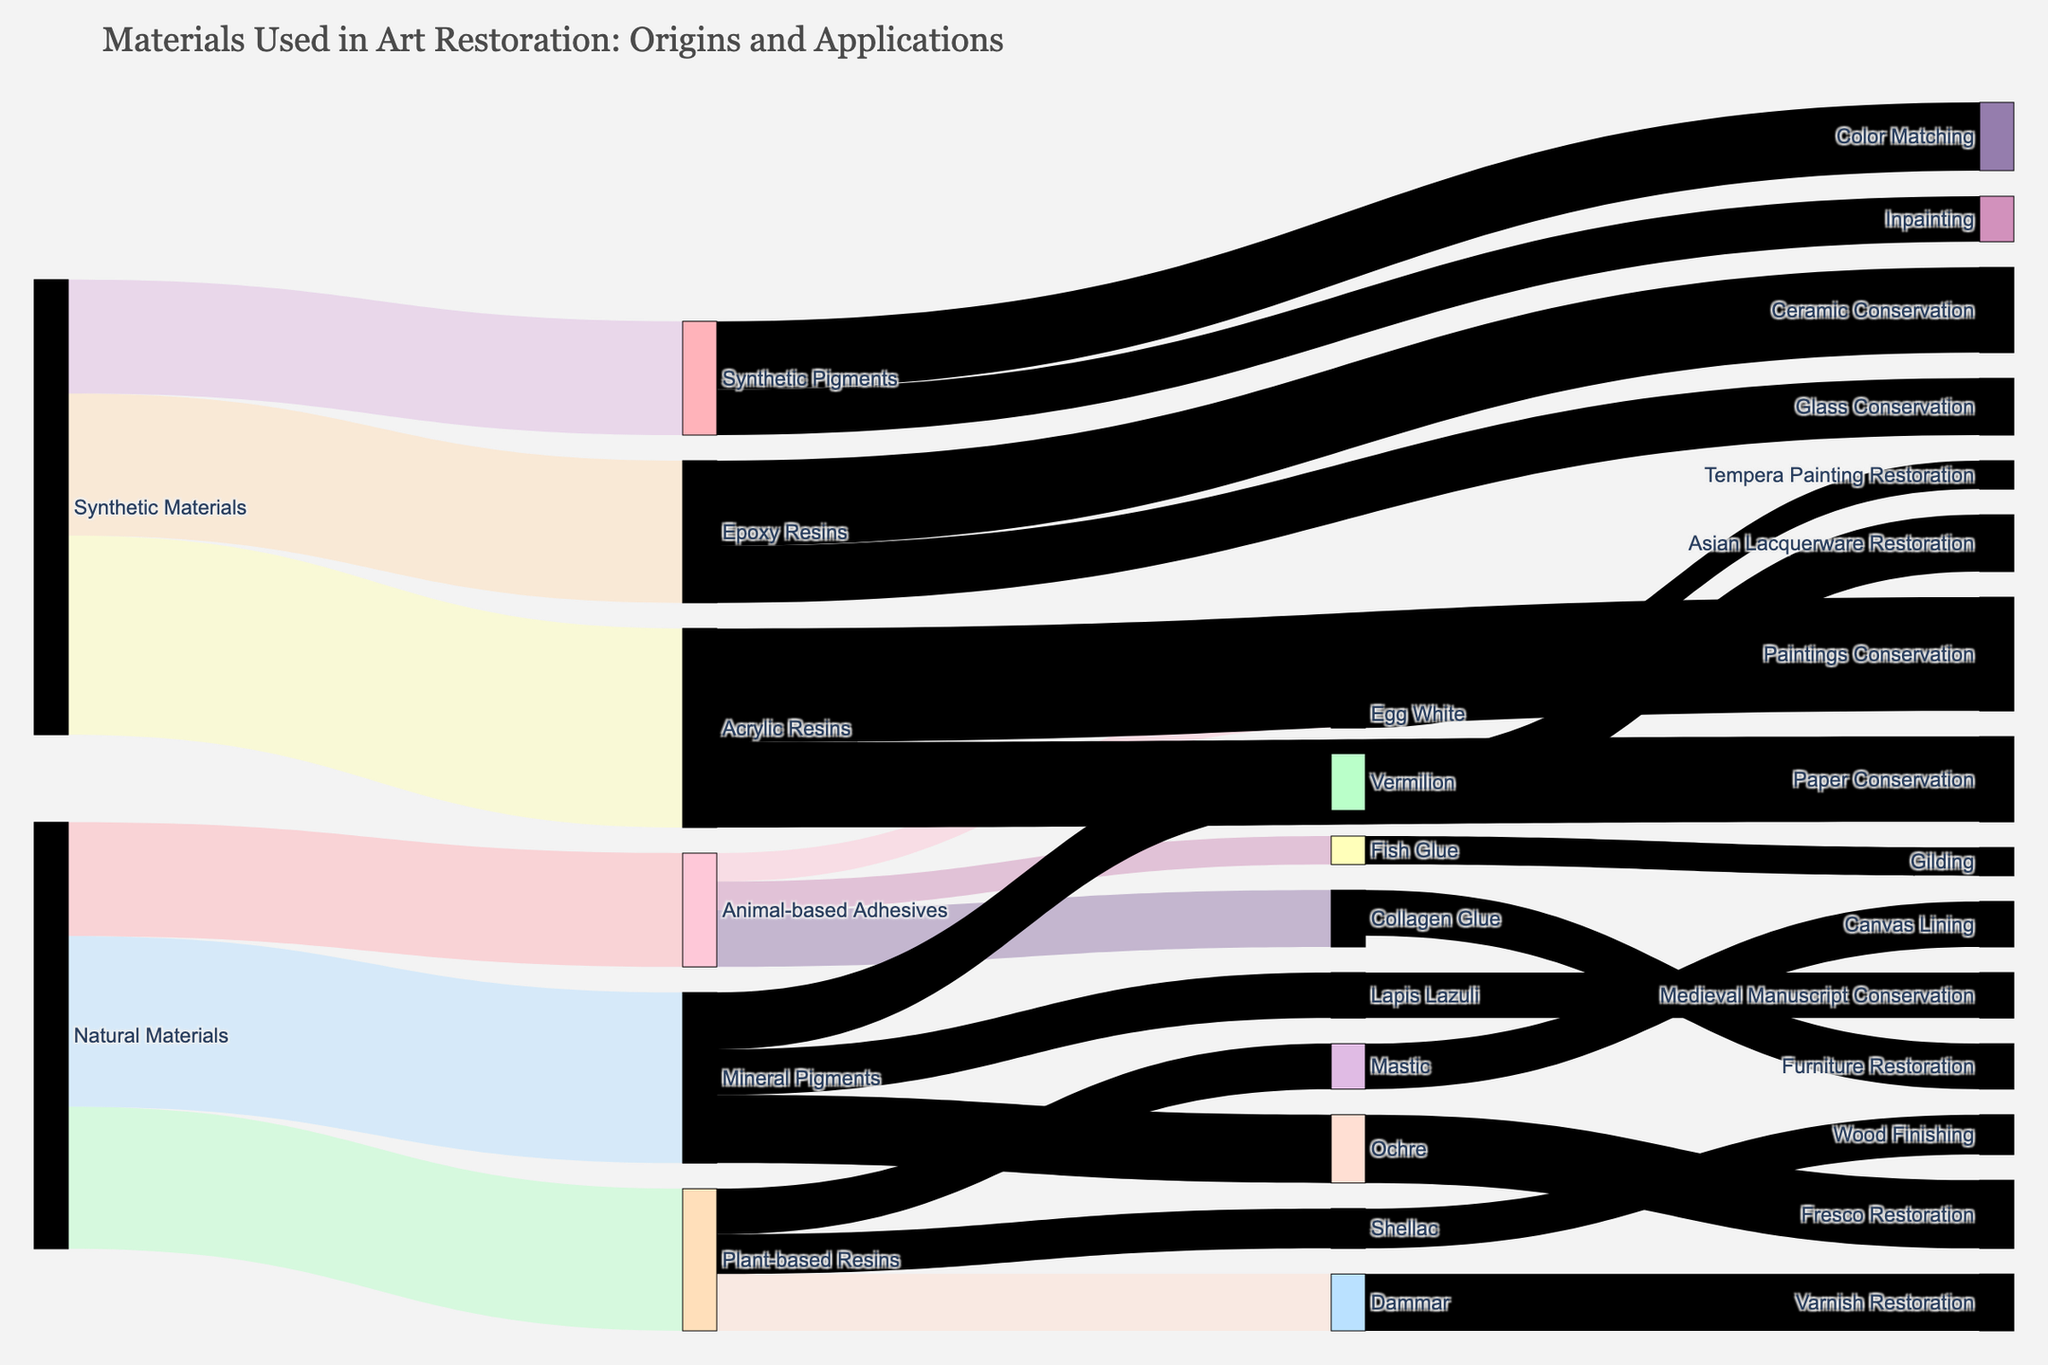How many natural material groups are shown in the figure? The natural material groups are "Animal-based Adhesives," "Plant-based Resins," and "Mineral Pigments." Count these three groups based on the figure's labels.
Answer: 3 Which material is the most common in synthetic materials based on the figure? Compare the values associated with "Acrylic Resins," "Epoxy Resins," and "Synthetic Pigments." "Acrylic Resins" has the highest value (35).
Answer: Acrylic Resins What is the total value of plant-based resins? Sum the values for "Dammar," "Mastic," and "Shellac" – 10, 8, and 7 respectively. The total is 10 + 8 + 7 = 25.
Answer: 25 Which specific adhesive is used for furniture restoration? Identify the specific adhesives sourced from "Animal-based Adhesives" and find the one linked to furniture restoration. "Collagen Glue" is used for furniture restoration.
Answer: Collagen Glue Compare the values of fresco restoration and gilding activities. Which one is higher? Look at the values associated with "Fresco Restoration" (12) and "Gilding" (5). Fresco Restoration has a higher value.
Answer: Fresco Restoration What applications are associated with synthetic pigments? Identify the targets of "Synthetic Pigments." They are "Color Matching" and "Inpainting."
Answer: Color Matching, Inpainting What’s the combined value of Marine Pigments used in Art Restoration? Marine Pigments include "Ochre," "Lapis Lazuli," and "Vermilion." Sum their values: 12 (Ochre) + 8 (Lapis Lazuli) + 10 (Vermilion) = 30.
Answer: 30 Which material is primarily used for varnish restoration? Check the target associated with "Dammar" which is part of "Plant-based Resins." "Dammar" is used for varnish restoration.
Answer: Dammar How many types of conservation applications use acrylic resins? Identify the applications linked to "Acrylic Resins." They are "Paintings Conservation" and "Paper Conservation," resulting in two types.
Answer: 2 